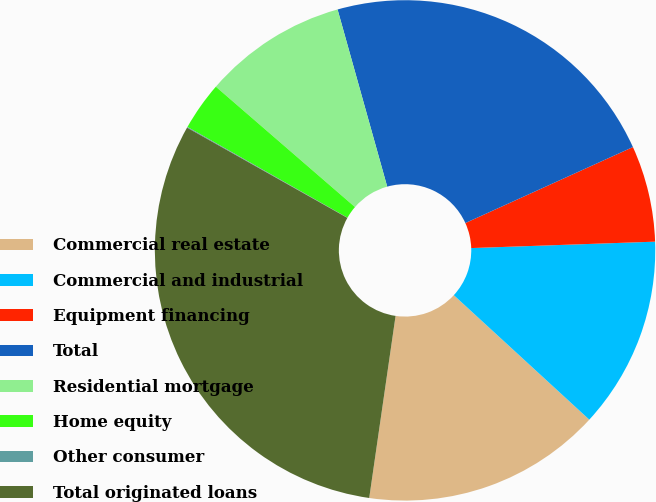Convert chart. <chart><loc_0><loc_0><loc_500><loc_500><pie_chart><fcel>Commercial real estate<fcel>Commercial and industrial<fcel>Equipment financing<fcel>Total<fcel>Residential mortgage<fcel>Home equity<fcel>Other consumer<fcel>Total originated loans<nl><fcel>15.46%<fcel>12.38%<fcel>6.22%<fcel>22.57%<fcel>9.3%<fcel>3.14%<fcel>0.05%<fcel>30.87%<nl></chart> 